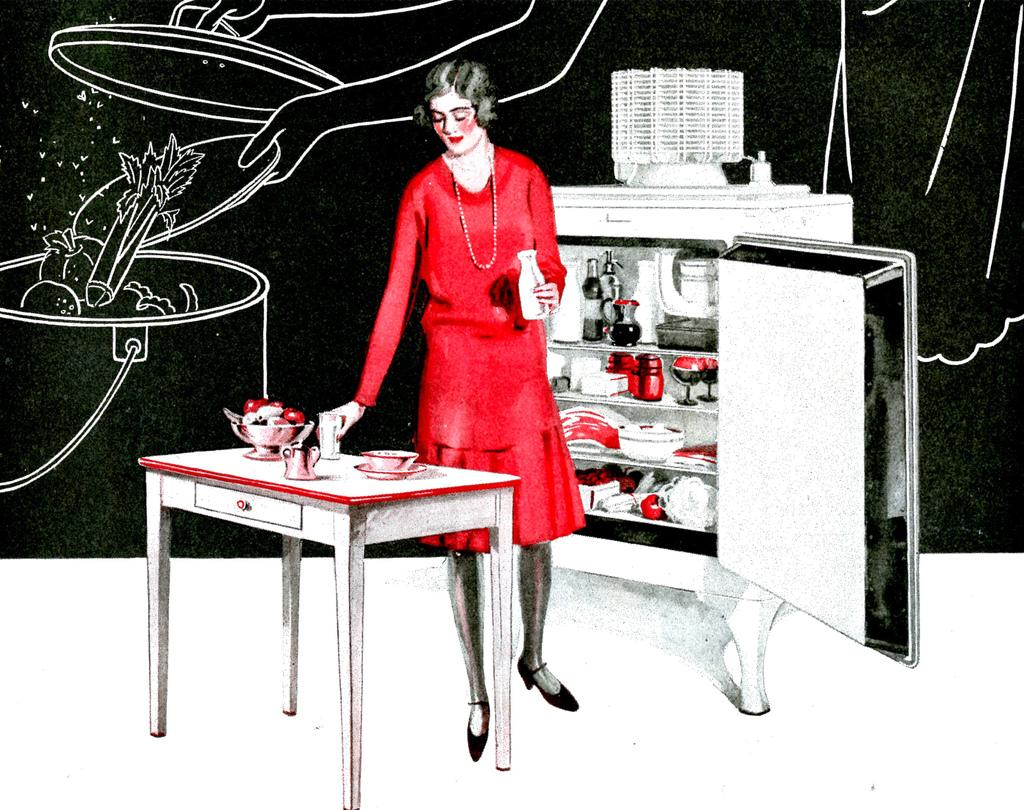Can you describe the main subject or theme of the transcript? The transcript does not provide a clear subject or theme, as it does not contain any specific information or facts. What type of show is being suggested in the transcript? There is no show or suggestion mentioned in the transcript, as it does not contain any specific information or facts. 